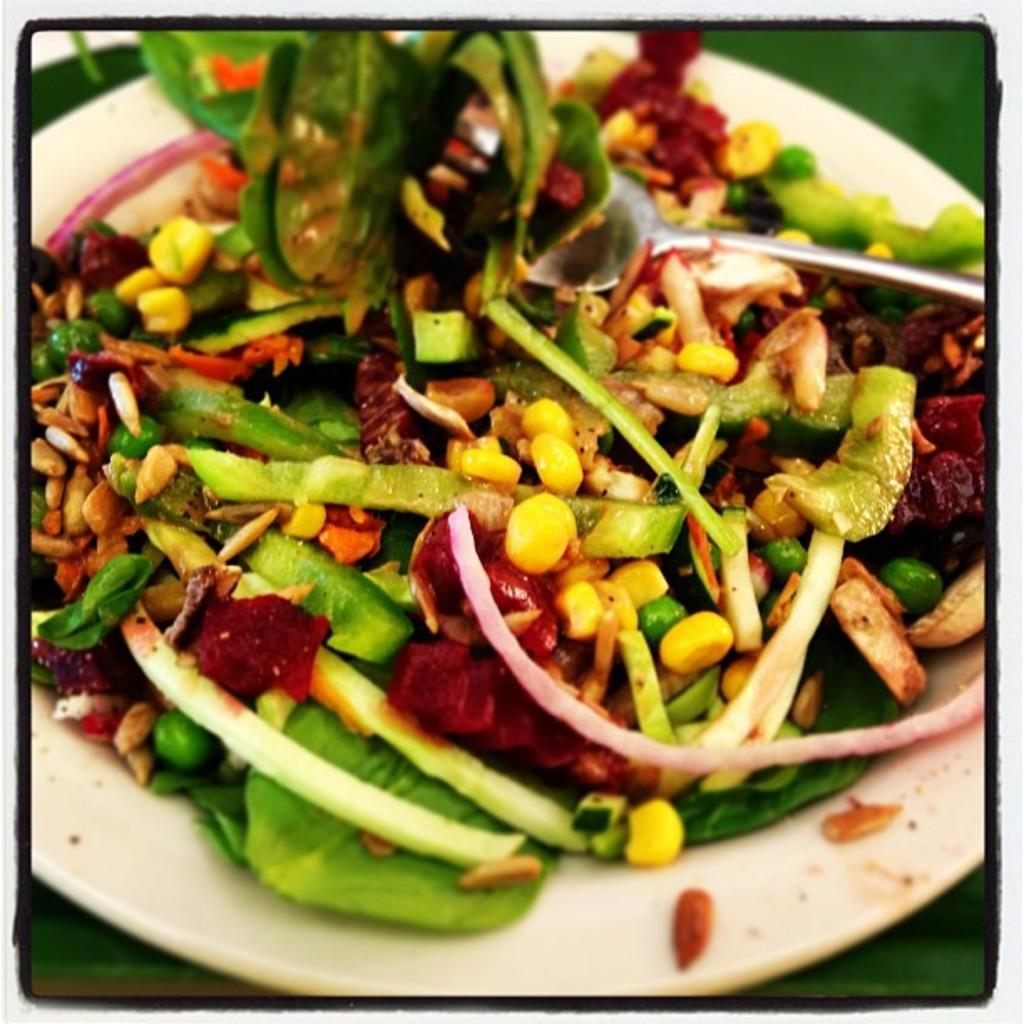What is the main object in the center of the image? There is a plate in the center of the image. What is on the plate? There is a food item on the plate. What type of sign can be seen on the plate in the image? There is no sign present on the plate in the image. What kind of insect is crawling on the food item in the image? There are no insects present on the food item in the image. 